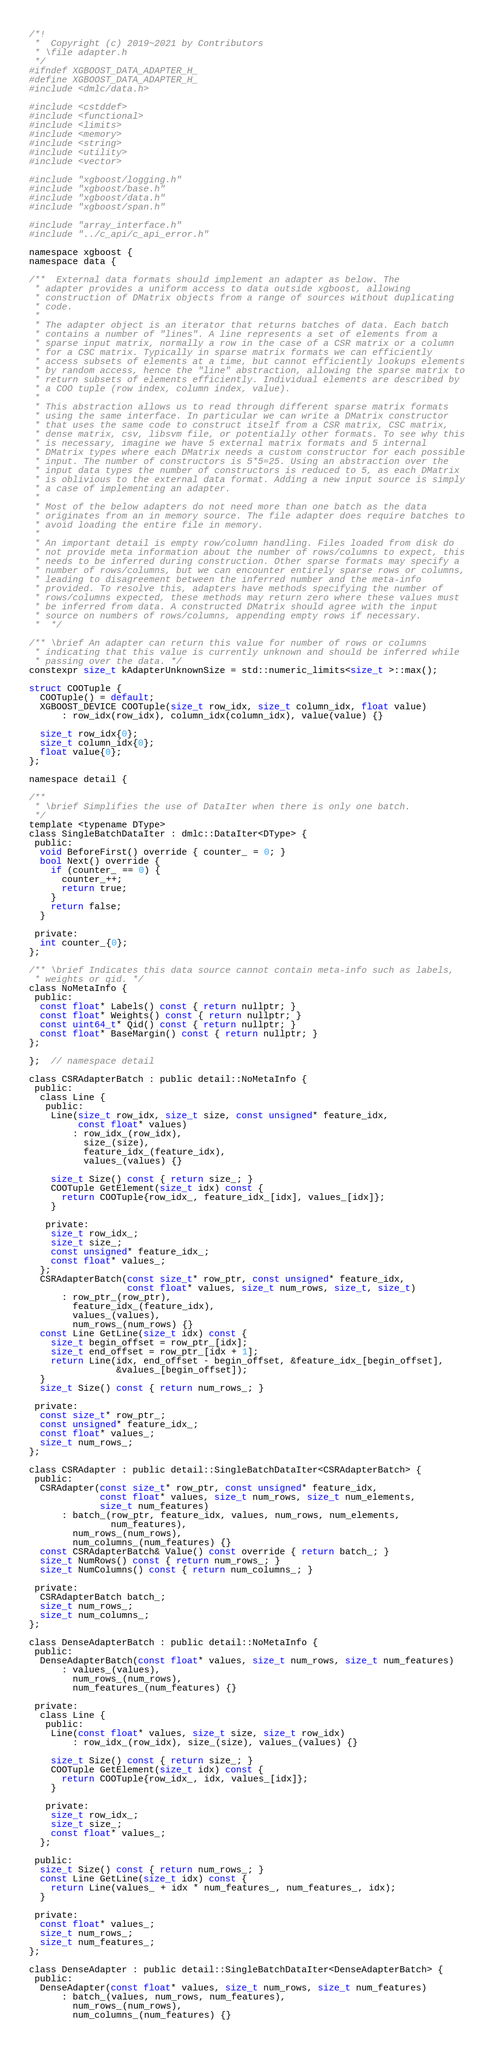<code> <loc_0><loc_0><loc_500><loc_500><_C_>/*!
 *  Copyright (c) 2019~2021 by Contributors
 * \file adapter.h
 */
#ifndef XGBOOST_DATA_ADAPTER_H_
#define XGBOOST_DATA_ADAPTER_H_
#include <dmlc/data.h>

#include <cstddef>
#include <functional>
#include <limits>
#include <memory>
#include <string>
#include <utility>
#include <vector>

#include "xgboost/logging.h"
#include "xgboost/base.h"
#include "xgboost/data.h"
#include "xgboost/span.h"

#include "array_interface.h"
#include "../c_api/c_api_error.h"

namespace xgboost {
namespace data {

/**  External data formats should implement an adapter as below. The
 * adapter provides a uniform access to data outside xgboost, allowing
 * construction of DMatrix objects from a range of sources without duplicating
 * code.
 *
 * The adapter object is an iterator that returns batches of data. Each batch
 * contains a number of "lines". A line represents a set of elements from a
 * sparse input matrix, normally a row in the case of a CSR matrix or a column
 * for a CSC matrix. Typically in sparse matrix formats we can efficiently
 * access subsets of elements at a time, but cannot efficiently lookups elements
 * by random access, hence the "line" abstraction, allowing the sparse matrix to
 * return subsets of elements efficiently. Individual elements are described by
 * a COO tuple (row index, column index, value).
 *
 * This abstraction allows us to read through different sparse matrix formats
 * using the same interface. In particular we can write a DMatrix constructor
 * that uses the same code to construct itself from a CSR matrix, CSC matrix,
 * dense matrix, csv, libsvm file, or potentially other formats. To see why this
 * is necessary, imagine we have 5 external matrix formats and 5 internal
 * DMatrix types where each DMatrix needs a custom constructor for each possible
 * input. The number of constructors is 5*5=25. Using an abstraction over the
 * input data types the number of constructors is reduced to 5, as each DMatrix
 * is oblivious to the external data format. Adding a new input source is simply
 * a case of implementing an adapter.
 *
 * Most of the below adapters do not need more than one batch as the data
 * originates from an in memory source. The file adapter does require batches to
 * avoid loading the entire file in memory.
 *
 * An important detail is empty row/column handling. Files loaded from disk do
 * not provide meta information about the number of rows/columns to expect, this
 * needs to be inferred during construction. Other sparse formats may specify a
 * number of rows/columns, but we can encounter entirely sparse rows or columns,
 * leading to disagreement between the inferred number and the meta-info
 * provided. To resolve this, adapters have methods specifying the number of
 * rows/columns expected, these methods may return zero where these values must
 * be inferred from data. A constructed DMatrix should agree with the input
 * source on numbers of rows/columns, appending empty rows if necessary.
 *  */

/** \brief An adapter can return this value for number of rows or columns
 * indicating that this value is currently unknown and should be inferred while
 * passing over the data. */
constexpr size_t kAdapterUnknownSize = std::numeric_limits<size_t >::max();

struct COOTuple {
  COOTuple() = default;
  XGBOOST_DEVICE COOTuple(size_t row_idx, size_t column_idx, float value)
      : row_idx(row_idx), column_idx(column_idx), value(value) {}

  size_t row_idx{0};
  size_t column_idx{0};
  float value{0};
};

namespace detail {

/**
 * \brief Simplifies the use of DataIter when there is only one batch.
 */
template <typename DType>
class SingleBatchDataIter : dmlc::DataIter<DType> {
 public:
  void BeforeFirst() override { counter_ = 0; }
  bool Next() override {
    if (counter_ == 0) {
      counter_++;
      return true;
    }
    return false;
  }

 private:
  int counter_{0};
};

/** \brief Indicates this data source cannot contain meta-info such as labels,
 * weights or qid. */
class NoMetaInfo {
 public:
  const float* Labels() const { return nullptr; }
  const float* Weights() const { return nullptr; }
  const uint64_t* Qid() const { return nullptr; }
  const float* BaseMargin() const { return nullptr; }
};

};  // namespace detail

class CSRAdapterBatch : public detail::NoMetaInfo {
 public:
  class Line {
   public:
    Line(size_t row_idx, size_t size, const unsigned* feature_idx,
         const float* values)
        : row_idx_(row_idx),
          size_(size),
          feature_idx_(feature_idx),
          values_(values) {}

    size_t Size() const { return size_; }
    COOTuple GetElement(size_t idx) const {
      return COOTuple{row_idx_, feature_idx_[idx], values_[idx]};
    }

   private:
    size_t row_idx_;
    size_t size_;
    const unsigned* feature_idx_;
    const float* values_;
  };
  CSRAdapterBatch(const size_t* row_ptr, const unsigned* feature_idx,
                  const float* values, size_t num_rows, size_t, size_t)
      : row_ptr_(row_ptr),
        feature_idx_(feature_idx),
        values_(values),
        num_rows_(num_rows) {}
  const Line GetLine(size_t idx) const {
    size_t begin_offset = row_ptr_[idx];
    size_t end_offset = row_ptr_[idx + 1];
    return Line(idx, end_offset - begin_offset, &feature_idx_[begin_offset],
                &values_[begin_offset]);
  }
  size_t Size() const { return num_rows_; }

 private:
  const size_t* row_ptr_;
  const unsigned* feature_idx_;
  const float* values_;
  size_t num_rows_;
};

class CSRAdapter : public detail::SingleBatchDataIter<CSRAdapterBatch> {
 public:
  CSRAdapter(const size_t* row_ptr, const unsigned* feature_idx,
             const float* values, size_t num_rows, size_t num_elements,
             size_t num_features)
      : batch_(row_ptr, feature_idx, values, num_rows, num_elements,
               num_features),
        num_rows_(num_rows),
        num_columns_(num_features) {}
  const CSRAdapterBatch& Value() const override { return batch_; }
  size_t NumRows() const { return num_rows_; }
  size_t NumColumns() const { return num_columns_; }

 private:
  CSRAdapterBatch batch_;
  size_t num_rows_;
  size_t num_columns_;
};

class DenseAdapterBatch : public detail::NoMetaInfo {
 public:
  DenseAdapterBatch(const float* values, size_t num_rows, size_t num_features)
      : values_(values),
        num_rows_(num_rows),
        num_features_(num_features) {}

 private:
  class Line {
   public:
    Line(const float* values, size_t size, size_t row_idx)
        : row_idx_(row_idx), size_(size), values_(values) {}

    size_t Size() const { return size_; }
    COOTuple GetElement(size_t idx) const {
      return COOTuple{row_idx_, idx, values_[idx]};
    }

   private:
    size_t row_idx_;
    size_t size_;
    const float* values_;
  };

 public:
  size_t Size() const { return num_rows_; }
  const Line GetLine(size_t idx) const {
    return Line(values_ + idx * num_features_, num_features_, idx);
  }

 private:
  const float* values_;
  size_t num_rows_;
  size_t num_features_;
};

class DenseAdapter : public detail::SingleBatchDataIter<DenseAdapterBatch> {
 public:
  DenseAdapter(const float* values, size_t num_rows, size_t num_features)
      : batch_(values, num_rows, num_features),
        num_rows_(num_rows),
        num_columns_(num_features) {}</code> 